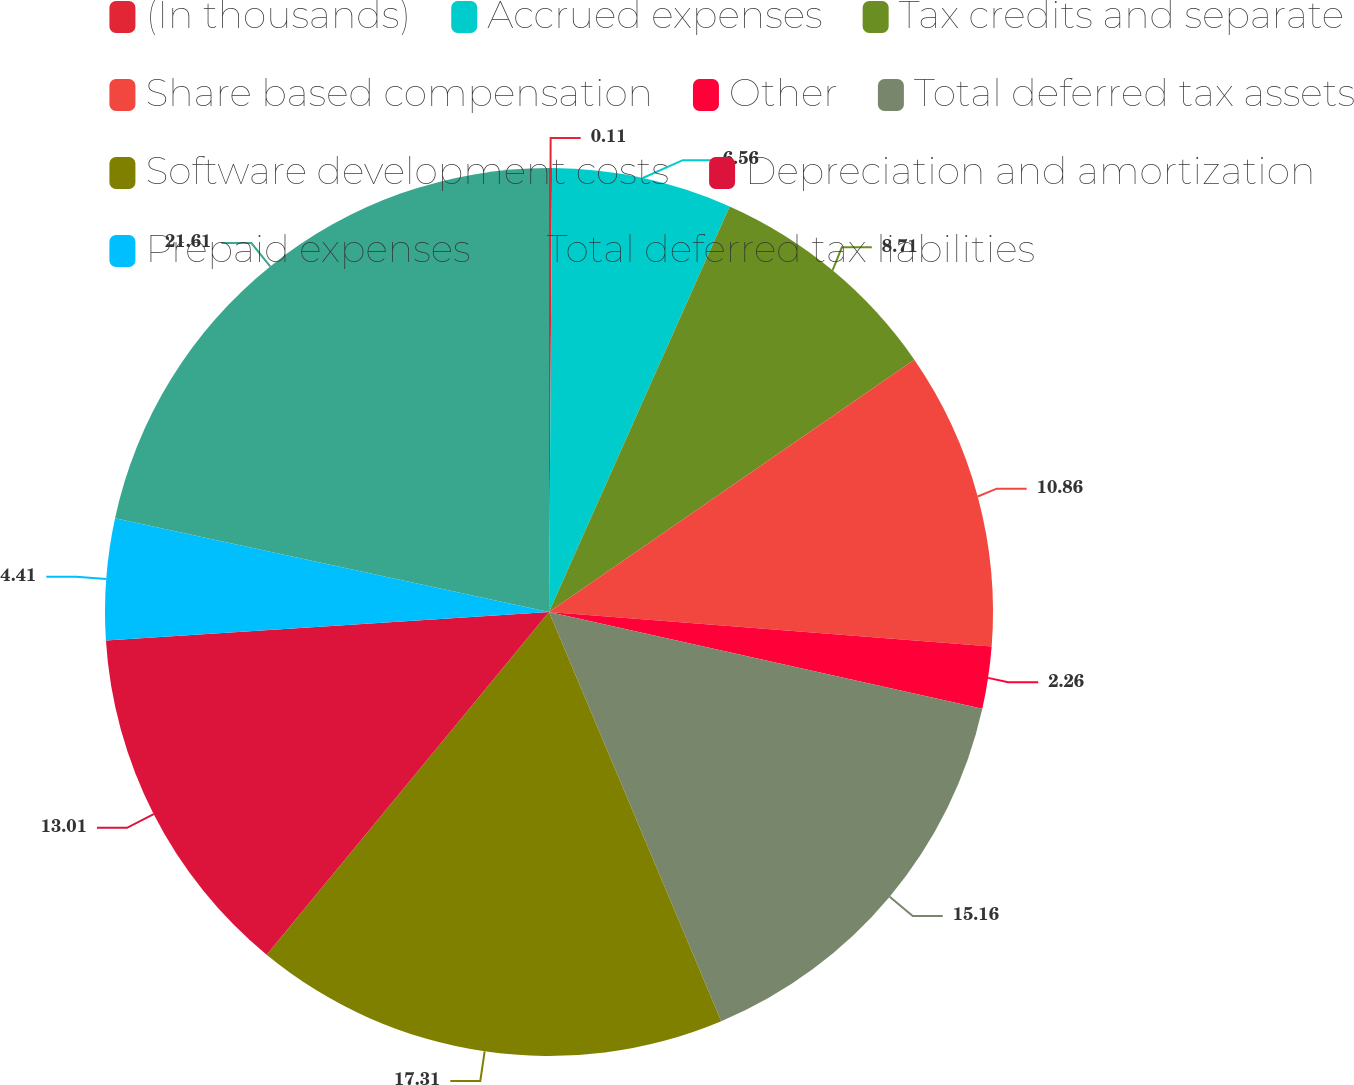Convert chart. <chart><loc_0><loc_0><loc_500><loc_500><pie_chart><fcel>(In thousands)<fcel>Accrued expenses<fcel>Tax credits and separate<fcel>Share based compensation<fcel>Other<fcel>Total deferred tax assets<fcel>Software development costs<fcel>Depreciation and amortization<fcel>Prepaid expenses<fcel>Total deferred tax liabilities<nl><fcel>0.11%<fcel>6.56%<fcel>8.71%<fcel>10.86%<fcel>2.26%<fcel>15.16%<fcel>17.31%<fcel>13.01%<fcel>4.41%<fcel>21.61%<nl></chart> 